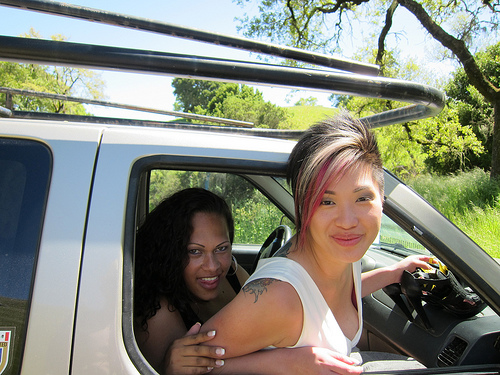<image>
Can you confirm if the woman is to the left of the van? No. The woman is not to the left of the van. From this viewpoint, they have a different horizontal relationship. 